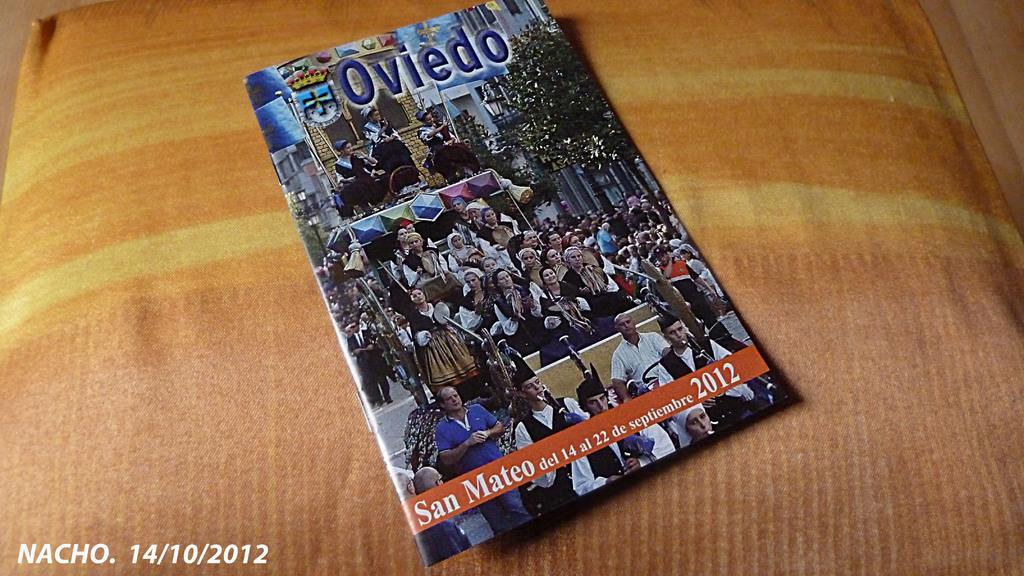<image>
Describe the image concisely. On a yellow cushion a book on Oviedo sits unopened. 